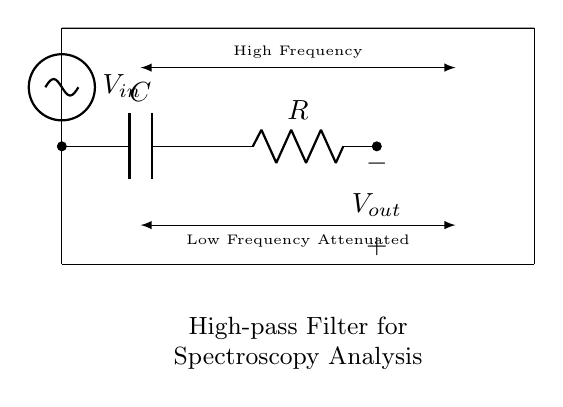What is the function of the capacitor in this circuit? The capacitor blocks low-frequency signals while allowing high-frequency signals to pass through, which is a characteristic feature of a high-pass filter.
Answer: Block low frequencies What is the value of the output voltage? The output voltage is represented as Vout; the actual numerical value is not provided in the diagram but can be inferred to be dependent on high-frequency input.
Answer: Vout What type of circuit is this? This is a high-pass filter circuit, specifically designed to isolate high-frequency components from a mixture of signals.
Answer: High-pass filter Which components are in series in this circuit? The capacitor and resistor are in series, allowing the circuit to manipulate the signal as required for filtering purposes.
Answer: Capacitor and Resistor What happens to low-frequency inputs in this filter? Low-frequency inputs are attenuated or reduced at the output, which indicates that they are effectively blocked by the filter.
Answer: Attenuated How do high-frequency signals behave in this circuit? High-frequency signals are passed through to the output, indicating the effectiveness of the high-pass filter in isolating these frequencies.
Answer: Passed through 